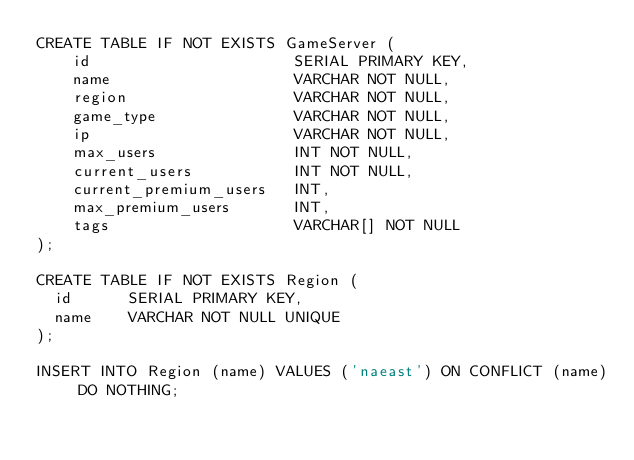<code> <loc_0><loc_0><loc_500><loc_500><_SQL_>CREATE TABLE IF NOT EXISTS GameServer (
    id                      SERIAL PRIMARY KEY,
    name                    VARCHAR NOT NULL,
    region                  VARCHAR NOT NULL,
    game_type               VARCHAR NOT NULL,
    ip                      VARCHAR NOT NULL,
    max_users               INT NOT NULL,
    current_users           INT NOT NULL,
    current_premium_users   INT,
    max_premium_users       INT,
    tags                    VARCHAR[] NOT NULL
);

CREATE TABLE IF NOT EXISTS Region (
	id			SERIAL PRIMARY KEY,
	name		VARCHAR NOT NULL UNIQUE
);

INSERT INTO Region (name) VALUES ('naeast') ON CONFLICT (name) DO NOTHING;</code> 